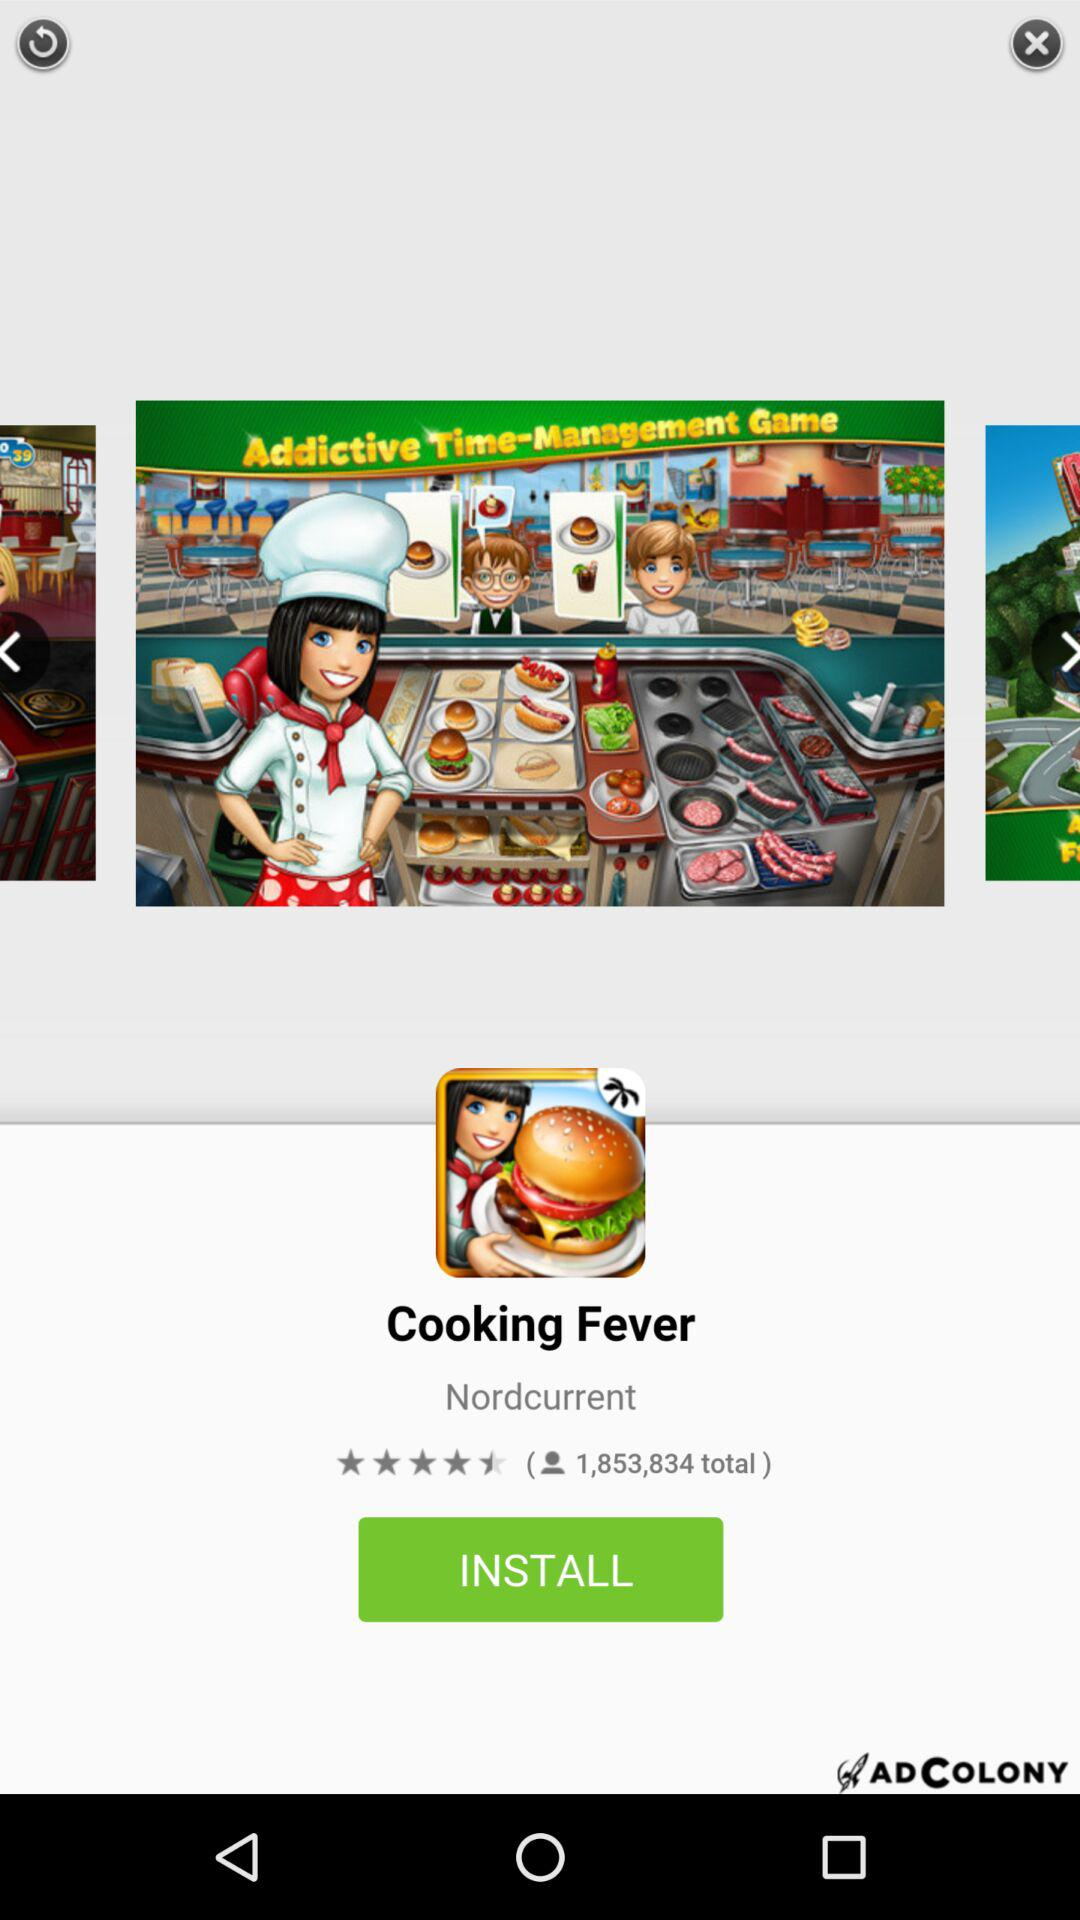How many people have reviewed the cooking game?
Answer the question using a single word or phrase. 1,853,834 